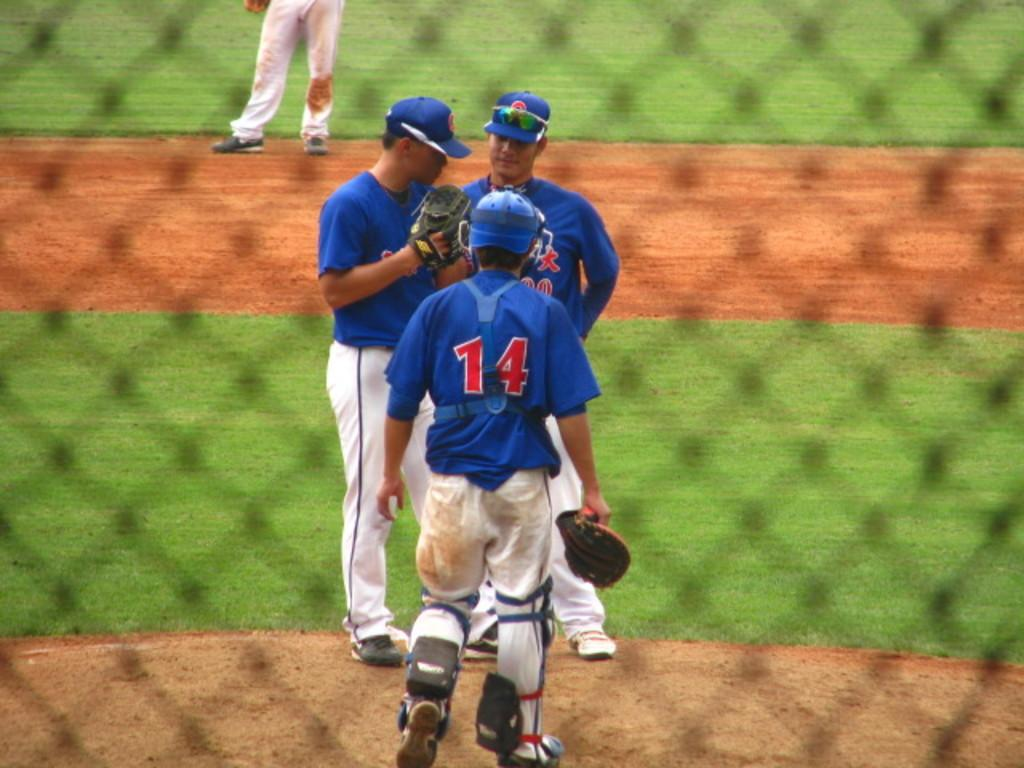Provide a one-sentence caption for the provided image. A catcher for a baseball team who wears the number 14 is meeting with the pitcher and coach on the mound. 